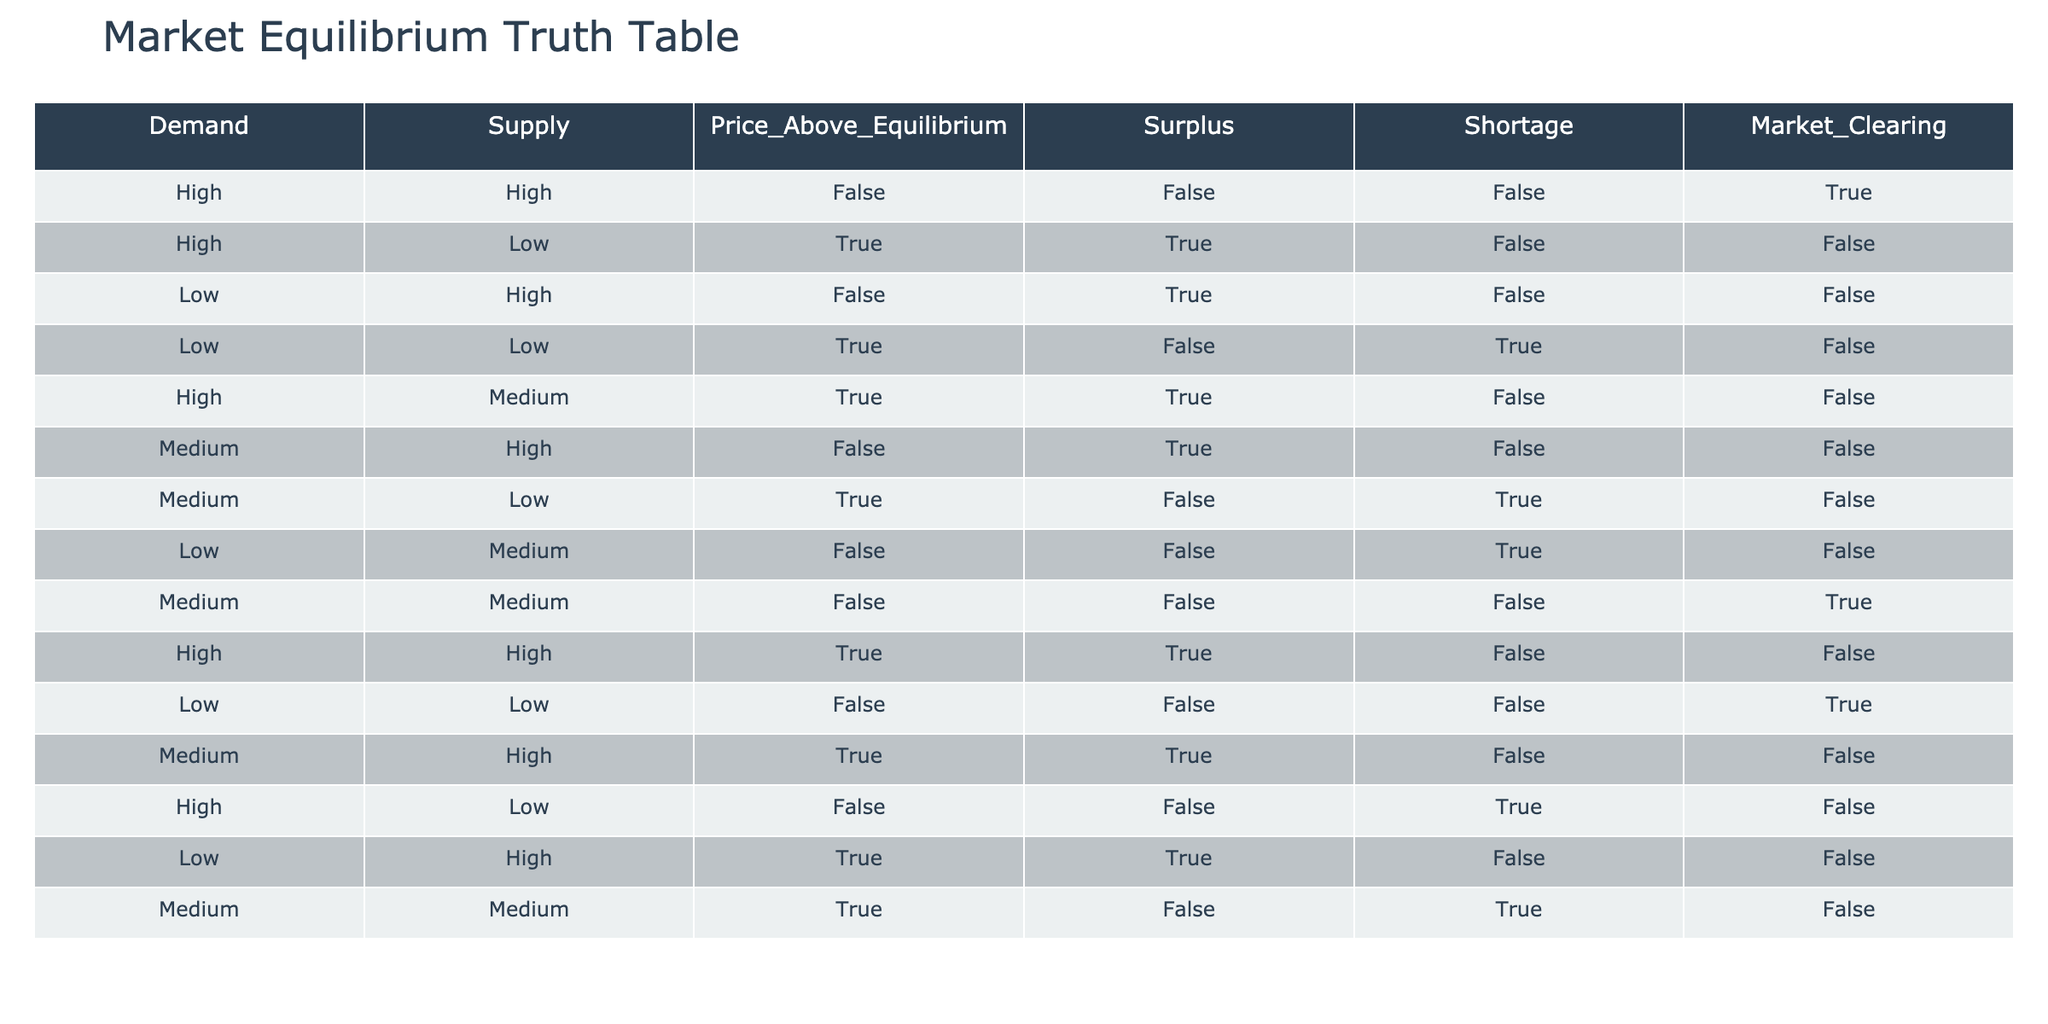What is the value of Market Clearing when Demand is Low and Supply is High? In the row where Demand is Low and Supply is High, the value in the Market Clearing column is False.
Answer: False How many conditions indicate a Surplus? Looking through the table, Surplus is indicated (True) in three conditions: High demand and Low supply, Low demand and High supply, Medium demand and Low supply, and Medium demand and Medium supply. Thus, there are four conditions.
Answer: 4 Is there a condition where Price is Above Equilibrium and Market Clearing is True? By checking the rows, we see that there are no instances where Price Above Equilibrium is True while Market Clearing is also True.
Answer: No What are the Demand and Supply conditions when there is Shortage? Shortage occurs when there are three combinations: High demand and Low supply, Low demand and High supply, and Low demand and Medium supply. Therefore, the conditions for Shortage are High-Low, Low-High, and Low-Medium.
Answer: High-Low, Low-High, Low-Medium In how many instances is Supply High? Scanning the Supply column, it is High in six conditions: High-High, Medium-High, Low-High, Medium-High, High-Low, and Low-High. Therefore, Supply is High in four instances.
Answer: 4 How many combinations result in both Surplus and Market Clearing being True? By examining the table, we find that Surplus and Market Clearing are both True only in the row where Demand is Medium and Supply is Medium. This results in one combination.
Answer: 1 What is the count of conditions that have Medium Demand? To determine this, we look for all rows where Demand equals Medium. There are four rows fitting this criterion, specifically showing counts when complemented with their corresponding Supply levels.
Answer: 4 Is there any condition where Demand is High and Market Clearing is True? Analyzing the conditions, we see that when Demand is High, Market Clearing is True only in the condition with High demand and high Supply.
Answer: Yes 